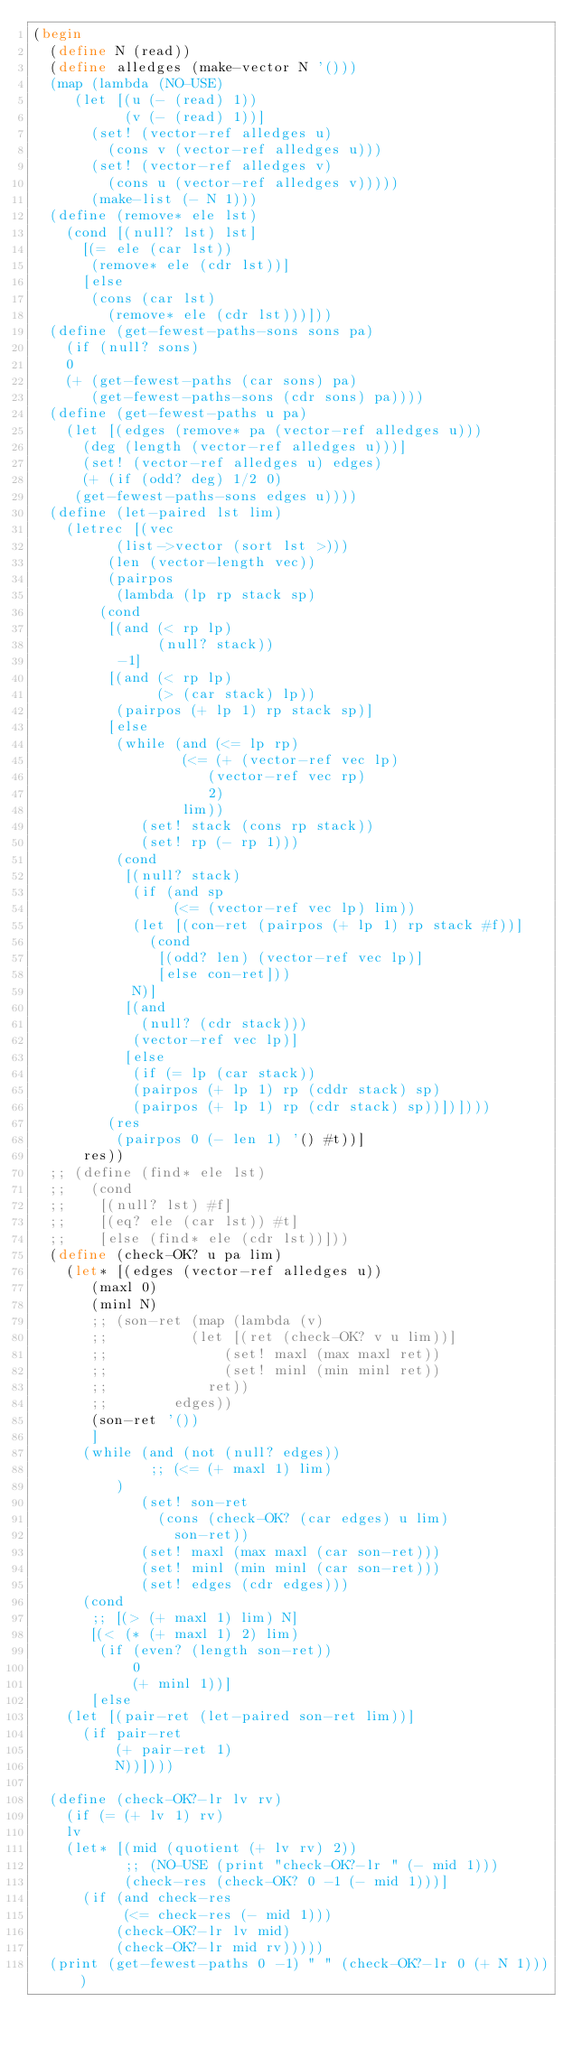<code> <loc_0><loc_0><loc_500><loc_500><_Scheme_>(begin
  (define N (read))
  (define alledges (make-vector N '()))
  (map (lambda (NO-USE)
	 (let [(u (- (read) 1))
	       (v (- (read) 1))]
	   (set! (vector-ref alledges u)
		 (cons v (vector-ref alledges u)))
	   (set! (vector-ref alledges v)
		 (cons u (vector-ref alledges v)))))
       (make-list (- N 1)))
  (define (remove* ele lst)
    (cond [(null? lst) lst]
	  [(= ele (car lst))
	   (remove* ele (cdr lst))]
	  [else
	   (cons (car lst)
		 (remove* ele (cdr lst)))]))
  (define (get-fewest-paths-sons sons pa)
    (if (null? sons)
	0
	(+ (get-fewest-paths (car sons) pa)
	   (get-fewest-paths-sons (cdr sons) pa))))
  (define (get-fewest-paths u pa)
    (let [(edges (remove* pa (vector-ref alledges u)))
	  (deg (length (vector-ref alledges u)))]
      (set! (vector-ref alledges u) edges)
      (+ (if (odd? deg) 1/2 0)
	 (get-fewest-paths-sons edges u))))
  (define (let-paired lst lim)
    (letrec [(vec
	      (list->vector (sort lst >)))
	     (len (vector-length vec))
	     (pairpos
	      (lambda (lp rp stack sp)
		(cond
		 [(and (< rp lp)
		       (null? stack))
		  -1]
		 [(and (< rp lp)
		       (> (car stack) lp))
		  (pairpos (+ lp 1) rp stack sp)]
		 [else
		  (while (and (<= lp rp)
			      (<= (+ (vector-ref vec lp)
				     (vector-ref vec rp)
				     2)
				  lim))
			 (set! stack (cons rp stack))
			 (set! rp (- rp 1)))
		  (cond
		   [(null? stack)
		    (if (and sp
			     (<= (vector-ref vec lp) lim))
			(let [(con-ret (pairpos (+ lp 1) rp stack #f))]
			  (cond
			   [(odd? len) (vector-ref vec lp)]
			   [else con-ret]))
			N)]
		   [(and
		     (null? (cdr stack)))
		    (vector-ref vec lp)]
		   [else
		    (if (= lp (car stack))
			(pairpos (+ lp 1) rp (cddr stack) sp)
			(pairpos (+ lp 1) rp (cdr stack) sp))])])))
	     (res
	      (pairpos 0 (- len 1) '() #t))]
      res))
  ;; (define (find* ele lst)
  ;;   (cond
  ;;    [(null? lst) #f]
  ;;    [(eq? ele (car lst)) #t]
  ;;    [else (find* ele (cdr lst))]))
  (define (check-OK? u pa lim)
    (let* [(edges (vector-ref alledges u))
	   (maxl 0)
	   (minl N)
	   ;; (son-ret (map (lambda (v)
	   ;; 		   (let [(ret (check-OK? v u lim))]
	   ;; 			   (set! maxl (max maxl ret))
	   ;; 			   (set! minl (min minl ret))
	   ;; 		     ret))
	   ;; 		 edges))
	   (son-ret '())
	   ]
      (while (and (not (null? edges))
      		  ;; (<= (+ maxl 1) lim)
		  )
      	     (set! son-ret
      		   (cons (check-OK? (car edges) u lim)
      			 son-ret))
      	     (set! maxl (max maxl (car son-ret)))
      	     (set! minl (min minl (car son-ret)))
      	     (set! edges (cdr edges)))
      (cond
       ;; [(> (+ maxl 1) lim) N]
       [(< (* (+ maxl 1) 2) lim)
       	(if (even? (length son-ret))
       	    0
       	    (+ minl 1))]
       [else
	(let [(pair-ret (let-paired son-ret lim))]
	  (if pair-ret
	      (+ pair-ret 1)
	      N))])))

  (define (check-OK?-lr lv rv)
    (if (= (+ lv 1) rv)
	lv
	(let* [(mid (quotient (+ lv rv) 2))
	       ;; (NO-USE (print "check-OK?-lr " (- mid 1)))
	       (check-res (check-OK? 0 -1 (- mid 1)))]
	  (if (and check-res
		   (<= check-res (- mid 1)))
	      (check-OK?-lr lv mid)
	      (check-OK?-lr mid rv)))))
  (print (get-fewest-paths 0 -1) " " (check-OK?-lr 0 (+ N 1))))
</code> 